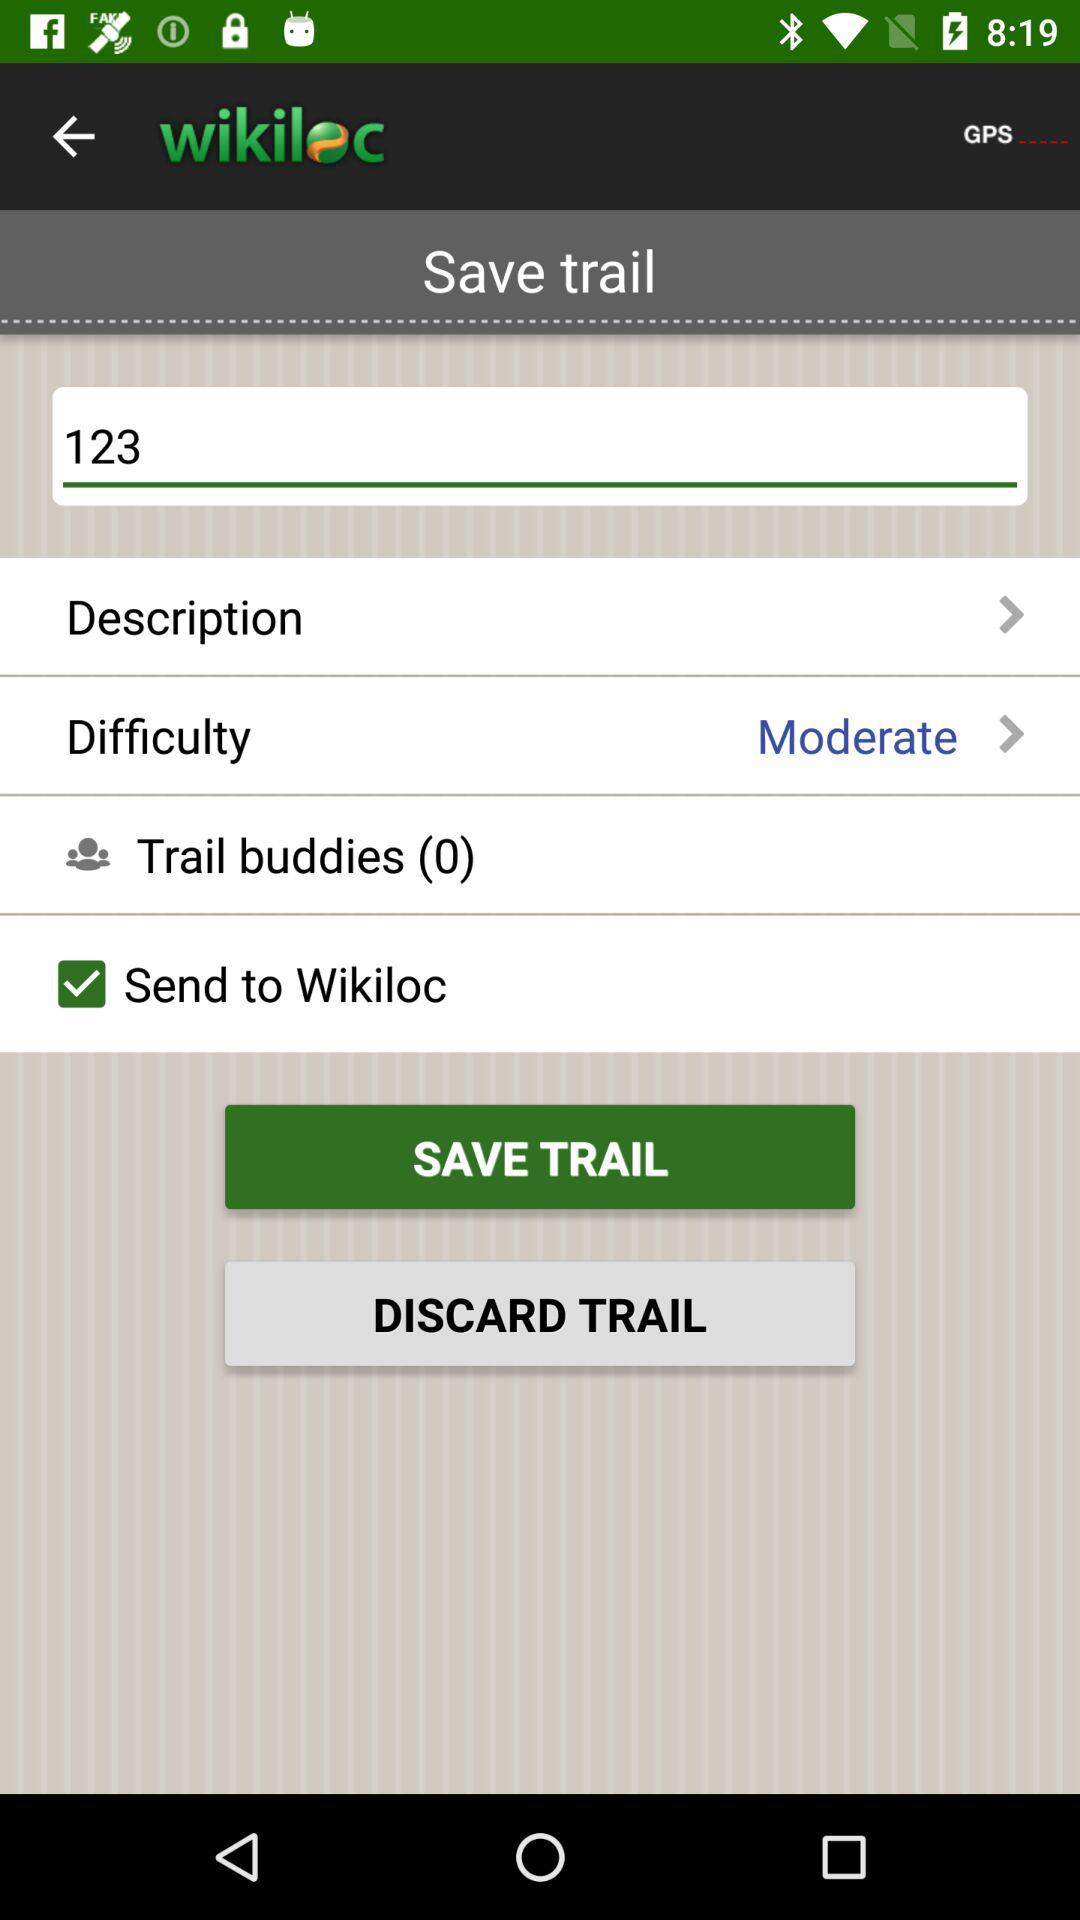How many trail buddies are there?
Answer the question using a single word or phrase. 0 